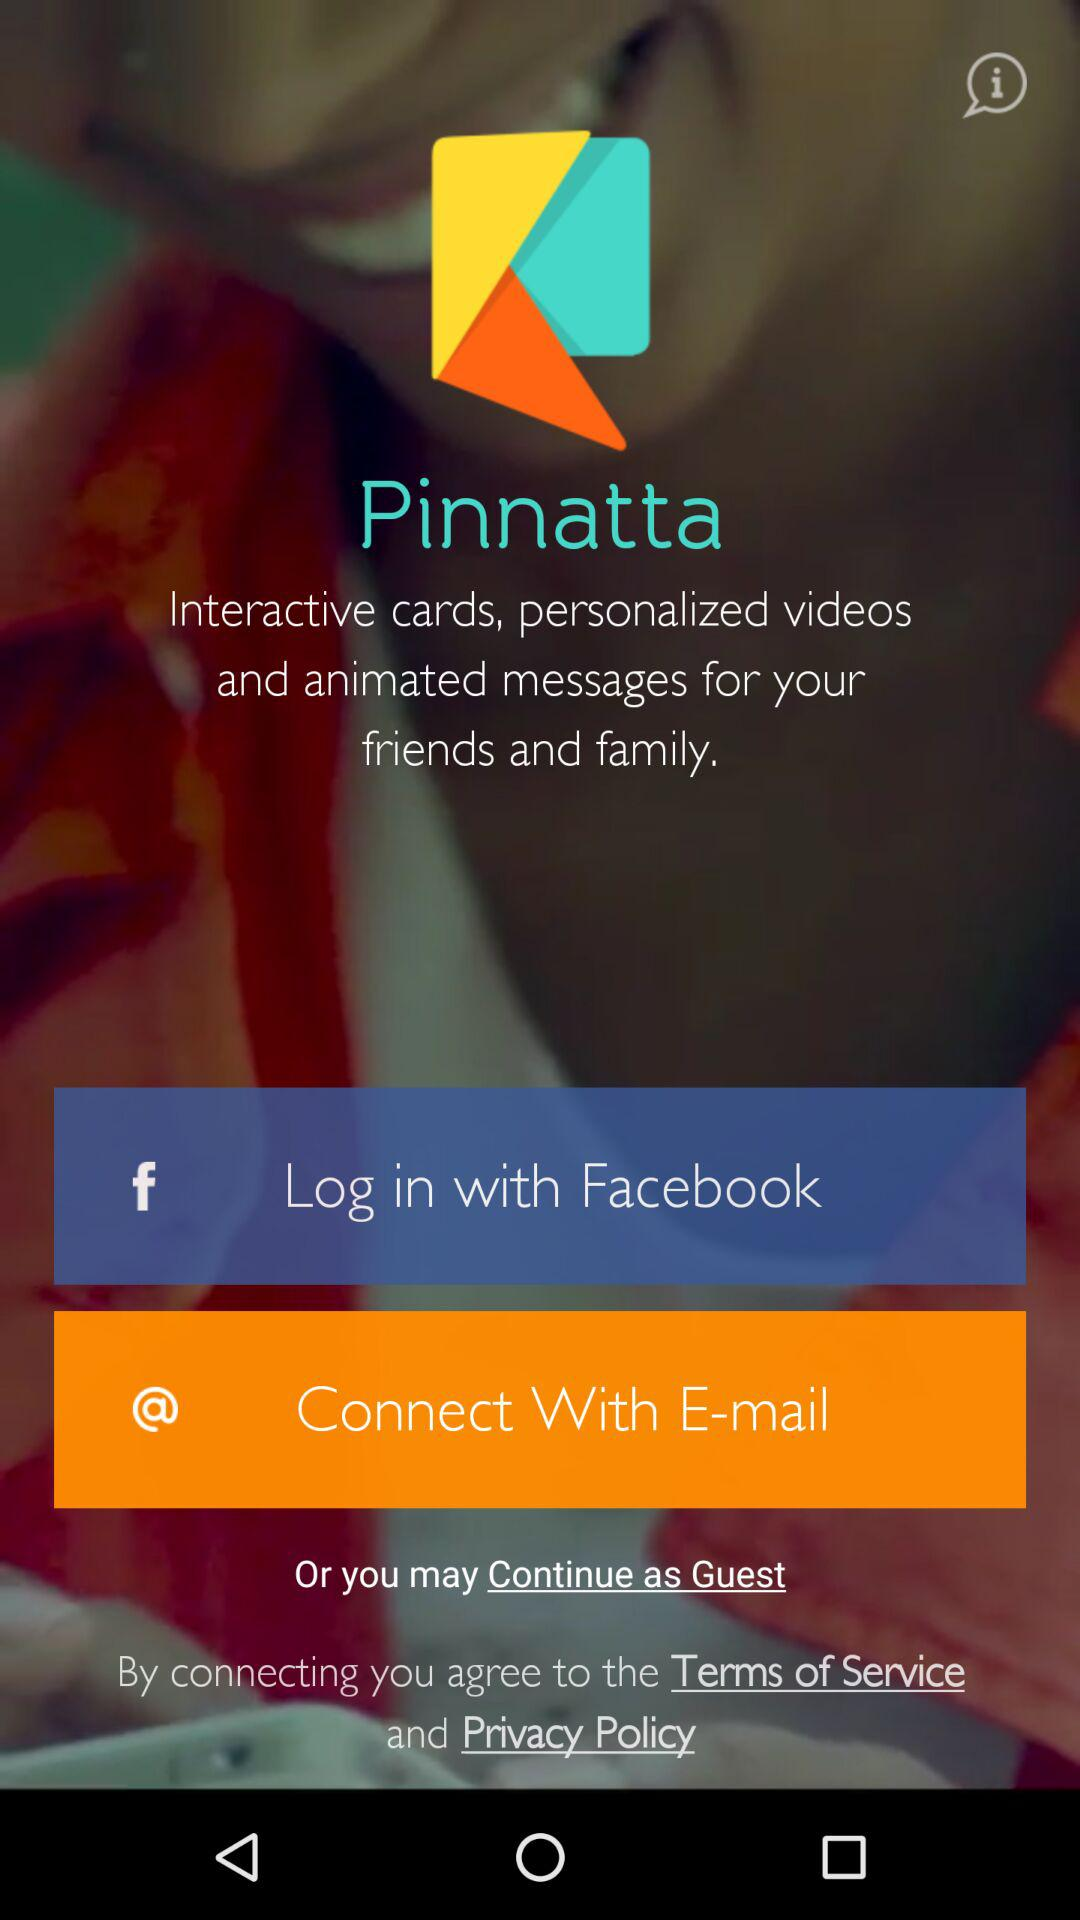What is the application name? The application name is "Pinnatta". 